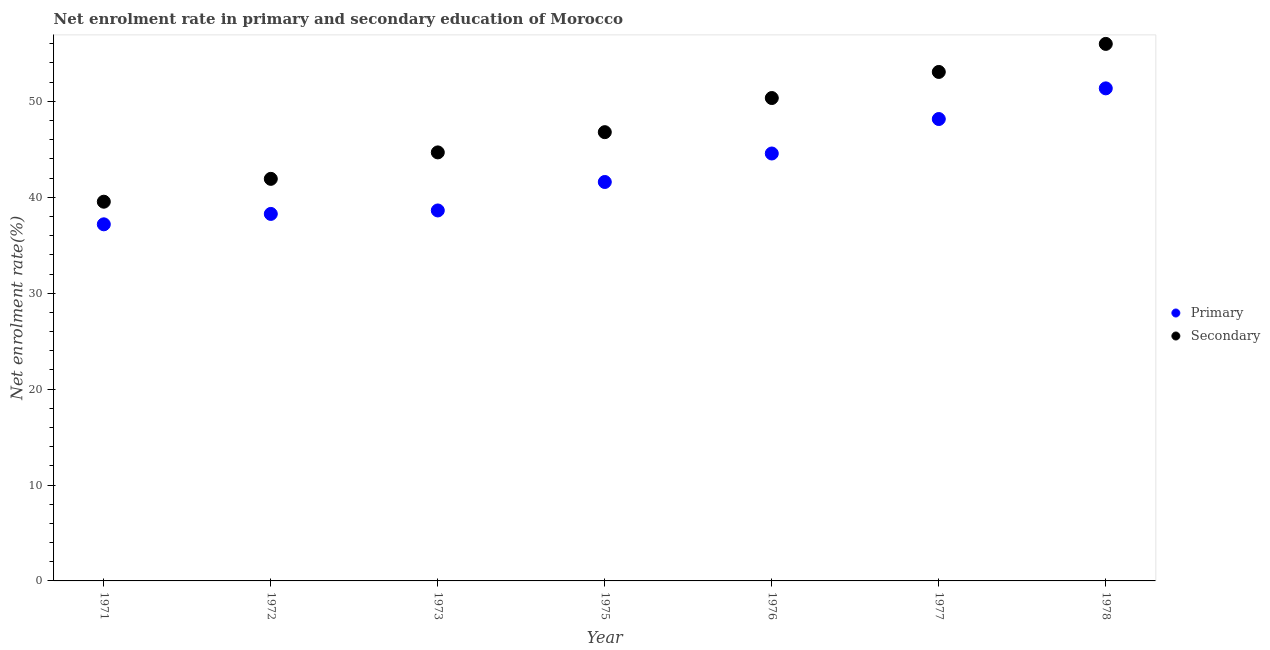How many different coloured dotlines are there?
Keep it short and to the point. 2. Is the number of dotlines equal to the number of legend labels?
Provide a succinct answer. Yes. What is the enrollment rate in secondary education in 1972?
Your answer should be very brief. 41.92. Across all years, what is the maximum enrollment rate in primary education?
Offer a terse response. 51.36. Across all years, what is the minimum enrollment rate in primary education?
Ensure brevity in your answer.  37.18. In which year was the enrollment rate in secondary education maximum?
Your answer should be very brief. 1978. In which year was the enrollment rate in primary education minimum?
Offer a terse response. 1971. What is the total enrollment rate in primary education in the graph?
Give a very brief answer. 299.74. What is the difference between the enrollment rate in primary education in 1973 and that in 1977?
Your response must be concise. -9.53. What is the difference between the enrollment rate in secondary education in 1976 and the enrollment rate in primary education in 1973?
Your response must be concise. 11.72. What is the average enrollment rate in primary education per year?
Offer a terse response. 42.82. In the year 1973, what is the difference between the enrollment rate in primary education and enrollment rate in secondary education?
Give a very brief answer. -6.05. In how many years, is the enrollment rate in secondary education greater than 6 %?
Make the answer very short. 7. What is the ratio of the enrollment rate in secondary education in 1972 to that in 1973?
Offer a terse response. 0.94. Is the enrollment rate in secondary education in 1976 less than that in 1978?
Your answer should be compact. Yes. What is the difference between the highest and the second highest enrollment rate in secondary education?
Ensure brevity in your answer.  2.92. What is the difference between the highest and the lowest enrollment rate in primary education?
Keep it short and to the point. 14.18. In how many years, is the enrollment rate in secondary education greater than the average enrollment rate in secondary education taken over all years?
Your answer should be very brief. 3. Is the enrollment rate in secondary education strictly greater than the enrollment rate in primary education over the years?
Your response must be concise. Yes. Is the enrollment rate in primary education strictly less than the enrollment rate in secondary education over the years?
Give a very brief answer. Yes. Where does the legend appear in the graph?
Provide a short and direct response. Center right. How are the legend labels stacked?
Give a very brief answer. Vertical. What is the title of the graph?
Ensure brevity in your answer.  Net enrolment rate in primary and secondary education of Morocco. What is the label or title of the X-axis?
Make the answer very short. Year. What is the label or title of the Y-axis?
Provide a succinct answer. Net enrolment rate(%). What is the Net enrolment rate(%) in Primary in 1971?
Offer a very short reply. 37.18. What is the Net enrolment rate(%) in Secondary in 1971?
Give a very brief answer. 39.54. What is the Net enrolment rate(%) in Primary in 1972?
Provide a succinct answer. 38.26. What is the Net enrolment rate(%) in Secondary in 1972?
Keep it short and to the point. 41.92. What is the Net enrolment rate(%) of Primary in 1973?
Provide a succinct answer. 38.63. What is the Net enrolment rate(%) in Secondary in 1973?
Make the answer very short. 44.68. What is the Net enrolment rate(%) in Primary in 1975?
Your response must be concise. 41.59. What is the Net enrolment rate(%) in Secondary in 1975?
Your answer should be compact. 46.79. What is the Net enrolment rate(%) of Primary in 1976?
Keep it short and to the point. 44.56. What is the Net enrolment rate(%) in Secondary in 1976?
Your answer should be compact. 50.35. What is the Net enrolment rate(%) in Primary in 1977?
Your response must be concise. 48.16. What is the Net enrolment rate(%) in Secondary in 1977?
Provide a short and direct response. 53.07. What is the Net enrolment rate(%) of Primary in 1978?
Keep it short and to the point. 51.36. What is the Net enrolment rate(%) in Secondary in 1978?
Provide a short and direct response. 55.99. Across all years, what is the maximum Net enrolment rate(%) in Primary?
Keep it short and to the point. 51.36. Across all years, what is the maximum Net enrolment rate(%) in Secondary?
Ensure brevity in your answer.  55.99. Across all years, what is the minimum Net enrolment rate(%) in Primary?
Provide a succinct answer. 37.18. Across all years, what is the minimum Net enrolment rate(%) of Secondary?
Ensure brevity in your answer.  39.54. What is the total Net enrolment rate(%) of Primary in the graph?
Ensure brevity in your answer.  299.74. What is the total Net enrolment rate(%) of Secondary in the graph?
Ensure brevity in your answer.  332.33. What is the difference between the Net enrolment rate(%) in Primary in 1971 and that in 1972?
Keep it short and to the point. -1.08. What is the difference between the Net enrolment rate(%) in Secondary in 1971 and that in 1972?
Provide a short and direct response. -2.38. What is the difference between the Net enrolment rate(%) of Primary in 1971 and that in 1973?
Offer a terse response. -1.45. What is the difference between the Net enrolment rate(%) of Secondary in 1971 and that in 1973?
Give a very brief answer. -5.14. What is the difference between the Net enrolment rate(%) in Primary in 1971 and that in 1975?
Offer a terse response. -4.41. What is the difference between the Net enrolment rate(%) in Secondary in 1971 and that in 1975?
Ensure brevity in your answer.  -7.25. What is the difference between the Net enrolment rate(%) of Primary in 1971 and that in 1976?
Your answer should be very brief. -7.38. What is the difference between the Net enrolment rate(%) of Secondary in 1971 and that in 1976?
Provide a short and direct response. -10.81. What is the difference between the Net enrolment rate(%) of Primary in 1971 and that in 1977?
Keep it short and to the point. -10.98. What is the difference between the Net enrolment rate(%) in Secondary in 1971 and that in 1977?
Keep it short and to the point. -13.53. What is the difference between the Net enrolment rate(%) of Primary in 1971 and that in 1978?
Offer a terse response. -14.18. What is the difference between the Net enrolment rate(%) in Secondary in 1971 and that in 1978?
Offer a very short reply. -16.45. What is the difference between the Net enrolment rate(%) of Primary in 1972 and that in 1973?
Provide a short and direct response. -0.36. What is the difference between the Net enrolment rate(%) of Secondary in 1972 and that in 1973?
Offer a very short reply. -2.76. What is the difference between the Net enrolment rate(%) of Primary in 1972 and that in 1975?
Your answer should be very brief. -3.33. What is the difference between the Net enrolment rate(%) of Secondary in 1972 and that in 1975?
Offer a very short reply. -4.87. What is the difference between the Net enrolment rate(%) of Primary in 1972 and that in 1976?
Provide a succinct answer. -6.3. What is the difference between the Net enrolment rate(%) in Secondary in 1972 and that in 1976?
Make the answer very short. -8.43. What is the difference between the Net enrolment rate(%) of Primary in 1972 and that in 1977?
Provide a short and direct response. -9.89. What is the difference between the Net enrolment rate(%) in Secondary in 1972 and that in 1977?
Provide a succinct answer. -11.15. What is the difference between the Net enrolment rate(%) of Primary in 1972 and that in 1978?
Your response must be concise. -13.09. What is the difference between the Net enrolment rate(%) of Secondary in 1972 and that in 1978?
Keep it short and to the point. -14.07. What is the difference between the Net enrolment rate(%) of Primary in 1973 and that in 1975?
Keep it short and to the point. -2.97. What is the difference between the Net enrolment rate(%) of Secondary in 1973 and that in 1975?
Offer a very short reply. -2.11. What is the difference between the Net enrolment rate(%) of Primary in 1973 and that in 1976?
Your answer should be compact. -5.94. What is the difference between the Net enrolment rate(%) of Secondary in 1973 and that in 1976?
Give a very brief answer. -5.67. What is the difference between the Net enrolment rate(%) in Primary in 1973 and that in 1977?
Give a very brief answer. -9.53. What is the difference between the Net enrolment rate(%) in Secondary in 1973 and that in 1977?
Give a very brief answer. -8.39. What is the difference between the Net enrolment rate(%) of Primary in 1973 and that in 1978?
Provide a short and direct response. -12.73. What is the difference between the Net enrolment rate(%) of Secondary in 1973 and that in 1978?
Offer a terse response. -11.31. What is the difference between the Net enrolment rate(%) of Primary in 1975 and that in 1976?
Provide a succinct answer. -2.97. What is the difference between the Net enrolment rate(%) of Secondary in 1975 and that in 1976?
Give a very brief answer. -3.56. What is the difference between the Net enrolment rate(%) in Primary in 1975 and that in 1977?
Your answer should be very brief. -6.56. What is the difference between the Net enrolment rate(%) in Secondary in 1975 and that in 1977?
Make the answer very short. -6.28. What is the difference between the Net enrolment rate(%) of Primary in 1975 and that in 1978?
Make the answer very short. -9.76. What is the difference between the Net enrolment rate(%) of Secondary in 1975 and that in 1978?
Ensure brevity in your answer.  -9.2. What is the difference between the Net enrolment rate(%) of Primary in 1976 and that in 1977?
Your answer should be compact. -3.59. What is the difference between the Net enrolment rate(%) of Secondary in 1976 and that in 1977?
Provide a succinct answer. -2.72. What is the difference between the Net enrolment rate(%) of Primary in 1976 and that in 1978?
Your response must be concise. -6.79. What is the difference between the Net enrolment rate(%) in Secondary in 1976 and that in 1978?
Your response must be concise. -5.64. What is the difference between the Net enrolment rate(%) of Primary in 1977 and that in 1978?
Your answer should be compact. -3.2. What is the difference between the Net enrolment rate(%) of Secondary in 1977 and that in 1978?
Provide a succinct answer. -2.92. What is the difference between the Net enrolment rate(%) in Primary in 1971 and the Net enrolment rate(%) in Secondary in 1972?
Ensure brevity in your answer.  -4.74. What is the difference between the Net enrolment rate(%) in Primary in 1971 and the Net enrolment rate(%) in Secondary in 1973?
Provide a succinct answer. -7.5. What is the difference between the Net enrolment rate(%) in Primary in 1971 and the Net enrolment rate(%) in Secondary in 1975?
Give a very brief answer. -9.61. What is the difference between the Net enrolment rate(%) in Primary in 1971 and the Net enrolment rate(%) in Secondary in 1976?
Offer a very short reply. -13.17. What is the difference between the Net enrolment rate(%) in Primary in 1971 and the Net enrolment rate(%) in Secondary in 1977?
Make the answer very short. -15.89. What is the difference between the Net enrolment rate(%) of Primary in 1971 and the Net enrolment rate(%) of Secondary in 1978?
Ensure brevity in your answer.  -18.81. What is the difference between the Net enrolment rate(%) in Primary in 1972 and the Net enrolment rate(%) in Secondary in 1973?
Give a very brief answer. -6.41. What is the difference between the Net enrolment rate(%) in Primary in 1972 and the Net enrolment rate(%) in Secondary in 1975?
Your response must be concise. -8.52. What is the difference between the Net enrolment rate(%) of Primary in 1972 and the Net enrolment rate(%) of Secondary in 1976?
Offer a terse response. -12.08. What is the difference between the Net enrolment rate(%) of Primary in 1972 and the Net enrolment rate(%) of Secondary in 1977?
Your answer should be compact. -14.8. What is the difference between the Net enrolment rate(%) in Primary in 1972 and the Net enrolment rate(%) in Secondary in 1978?
Ensure brevity in your answer.  -17.73. What is the difference between the Net enrolment rate(%) in Primary in 1973 and the Net enrolment rate(%) in Secondary in 1975?
Make the answer very short. -8.16. What is the difference between the Net enrolment rate(%) of Primary in 1973 and the Net enrolment rate(%) of Secondary in 1976?
Your response must be concise. -11.72. What is the difference between the Net enrolment rate(%) of Primary in 1973 and the Net enrolment rate(%) of Secondary in 1977?
Your answer should be compact. -14.44. What is the difference between the Net enrolment rate(%) in Primary in 1973 and the Net enrolment rate(%) in Secondary in 1978?
Offer a terse response. -17.37. What is the difference between the Net enrolment rate(%) in Primary in 1975 and the Net enrolment rate(%) in Secondary in 1976?
Give a very brief answer. -8.75. What is the difference between the Net enrolment rate(%) in Primary in 1975 and the Net enrolment rate(%) in Secondary in 1977?
Ensure brevity in your answer.  -11.47. What is the difference between the Net enrolment rate(%) of Primary in 1975 and the Net enrolment rate(%) of Secondary in 1978?
Ensure brevity in your answer.  -14.4. What is the difference between the Net enrolment rate(%) in Primary in 1976 and the Net enrolment rate(%) in Secondary in 1977?
Give a very brief answer. -8.5. What is the difference between the Net enrolment rate(%) in Primary in 1976 and the Net enrolment rate(%) in Secondary in 1978?
Your answer should be compact. -11.43. What is the difference between the Net enrolment rate(%) in Primary in 1977 and the Net enrolment rate(%) in Secondary in 1978?
Keep it short and to the point. -7.83. What is the average Net enrolment rate(%) in Primary per year?
Provide a short and direct response. 42.82. What is the average Net enrolment rate(%) in Secondary per year?
Your response must be concise. 47.48. In the year 1971, what is the difference between the Net enrolment rate(%) in Primary and Net enrolment rate(%) in Secondary?
Make the answer very short. -2.36. In the year 1972, what is the difference between the Net enrolment rate(%) of Primary and Net enrolment rate(%) of Secondary?
Your response must be concise. -3.66. In the year 1973, what is the difference between the Net enrolment rate(%) in Primary and Net enrolment rate(%) in Secondary?
Your answer should be very brief. -6.05. In the year 1975, what is the difference between the Net enrolment rate(%) of Primary and Net enrolment rate(%) of Secondary?
Your response must be concise. -5.19. In the year 1976, what is the difference between the Net enrolment rate(%) of Primary and Net enrolment rate(%) of Secondary?
Your response must be concise. -5.78. In the year 1977, what is the difference between the Net enrolment rate(%) of Primary and Net enrolment rate(%) of Secondary?
Make the answer very short. -4.91. In the year 1978, what is the difference between the Net enrolment rate(%) in Primary and Net enrolment rate(%) in Secondary?
Give a very brief answer. -4.64. What is the ratio of the Net enrolment rate(%) in Primary in 1971 to that in 1972?
Provide a short and direct response. 0.97. What is the ratio of the Net enrolment rate(%) of Secondary in 1971 to that in 1972?
Give a very brief answer. 0.94. What is the ratio of the Net enrolment rate(%) of Primary in 1971 to that in 1973?
Offer a very short reply. 0.96. What is the ratio of the Net enrolment rate(%) of Secondary in 1971 to that in 1973?
Your answer should be compact. 0.89. What is the ratio of the Net enrolment rate(%) of Primary in 1971 to that in 1975?
Make the answer very short. 0.89. What is the ratio of the Net enrolment rate(%) of Secondary in 1971 to that in 1975?
Offer a very short reply. 0.84. What is the ratio of the Net enrolment rate(%) in Primary in 1971 to that in 1976?
Give a very brief answer. 0.83. What is the ratio of the Net enrolment rate(%) in Secondary in 1971 to that in 1976?
Provide a succinct answer. 0.79. What is the ratio of the Net enrolment rate(%) of Primary in 1971 to that in 1977?
Ensure brevity in your answer.  0.77. What is the ratio of the Net enrolment rate(%) in Secondary in 1971 to that in 1977?
Keep it short and to the point. 0.75. What is the ratio of the Net enrolment rate(%) of Primary in 1971 to that in 1978?
Your response must be concise. 0.72. What is the ratio of the Net enrolment rate(%) in Secondary in 1971 to that in 1978?
Give a very brief answer. 0.71. What is the ratio of the Net enrolment rate(%) in Primary in 1972 to that in 1973?
Provide a succinct answer. 0.99. What is the ratio of the Net enrolment rate(%) in Secondary in 1972 to that in 1973?
Your response must be concise. 0.94. What is the ratio of the Net enrolment rate(%) in Primary in 1972 to that in 1975?
Your response must be concise. 0.92. What is the ratio of the Net enrolment rate(%) of Secondary in 1972 to that in 1975?
Keep it short and to the point. 0.9. What is the ratio of the Net enrolment rate(%) in Primary in 1972 to that in 1976?
Keep it short and to the point. 0.86. What is the ratio of the Net enrolment rate(%) in Secondary in 1972 to that in 1976?
Make the answer very short. 0.83. What is the ratio of the Net enrolment rate(%) in Primary in 1972 to that in 1977?
Offer a terse response. 0.79. What is the ratio of the Net enrolment rate(%) in Secondary in 1972 to that in 1977?
Your response must be concise. 0.79. What is the ratio of the Net enrolment rate(%) in Primary in 1972 to that in 1978?
Offer a terse response. 0.75. What is the ratio of the Net enrolment rate(%) in Secondary in 1972 to that in 1978?
Provide a short and direct response. 0.75. What is the ratio of the Net enrolment rate(%) in Secondary in 1973 to that in 1975?
Your answer should be compact. 0.95. What is the ratio of the Net enrolment rate(%) of Primary in 1973 to that in 1976?
Provide a succinct answer. 0.87. What is the ratio of the Net enrolment rate(%) in Secondary in 1973 to that in 1976?
Ensure brevity in your answer.  0.89. What is the ratio of the Net enrolment rate(%) of Primary in 1973 to that in 1977?
Provide a succinct answer. 0.8. What is the ratio of the Net enrolment rate(%) in Secondary in 1973 to that in 1977?
Your answer should be very brief. 0.84. What is the ratio of the Net enrolment rate(%) in Primary in 1973 to that in 1978?
Ensure brevity in your answer.  0.75. What is the ratio of the Net enrolment rate(%) in Secondary in 1973 to that in 1978?
Your response must be concise. 0.8. What is the ratio of the Net enrolment rate(%) in Primary in 1975 to that in 1976?
Offer a very short reply. 0.93. What is the ratio of the Net enrolment rate(%) in Secondary in 1975 to that in 1976?
Keep it short and to the point. 0.93. What is the ratio of the Net enrolment rate(%) in Primary in 1975 to that in 1977?
Ensure brevity in your answer.  0.86. What is the ratio of the Net enrolment rate(%) of Secondary in 1975 to that in 1977?
Provide a short and direct response. 0.88. What is the ratio of the Net enrolment rate(%) in Primary in 1975 to that in 1978?
Your answer should be compact. 0.81. What is the ratio of the Net enrolment rate(%) of Secondary in 1975 to that in 1978?
Offer a very short reply. 0.84. What is the ratio of the Net enrolment rate(%) in Primary in 1976 to that in 1977?
Ensure brevity in your answer.  0.93. What is the ratio of the Net enrolment rate(%) in Secondary in 1976 to that in 1977?
Offer a very short reply. 0.95. What is the ratio of the Net enrolment rate(%) of Primary in 1976 to that in 1978?
Provide a succinct answer. 0.87. What is the ratio of the Net enrolment rate(%) of Secondary in 1976 to that in 1978?
Your response must be concise. 0.9. What is the ratio of the Net enrolment rate(%) of Primary in 1977 to that in 1978?
Keep it short and to the point. 0.94. What is the ratio of the Net enrolment rate(%) of Secondary in 1977 to that in 1978?
Make the answer very short. 0.95. What is the difference between the highest and the second highest Net enrolment rate(%) in Primary?
Your answer should be compact. 3.2. What is the difference between the highest and the second highest Net enrolment rate(%) of Secondary?
Make the answer very short. 2.92. What is the difference between the highest and the lowest Net enrolment rate(%) in Primary?
Keep it short and to the point. 14.18. What is the difference between the highest and the lowest Net enrolment rate(%) of Secondary?
Keep it short and to the point. 16.45. 